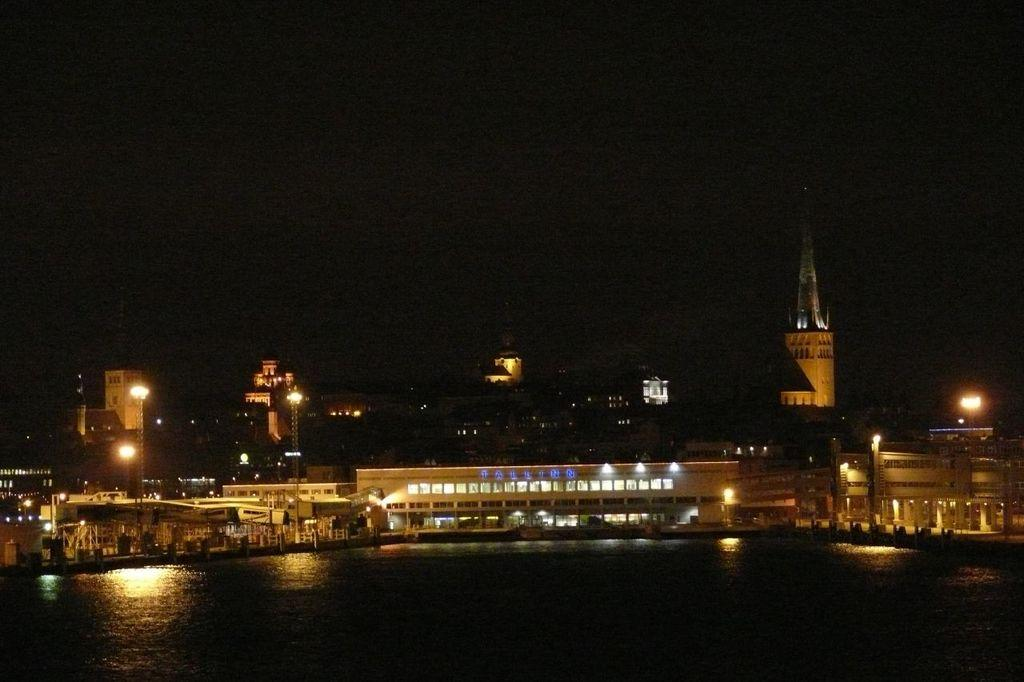What type of structure is present in the image? There is a building in the image. What feature of the building is mentioned in the facts? The building has lights. What natural element is visible in front of the building? There is water visible in front of the building. How would you describe the overall lighting in the image? The background of the image is dark. Can you see any cracks in the building's foundation in the image? There is no mention of cracks in the building's foundation in the provided facts, so we cannot determine their presence from the image. --- Facts: 1. There is a person sitting on a chair in the image. 2. The person is holding a book. 3. The chair is made of wood. 4. There is a table next to the chair. 5. The table has a lamp on it. Absurd Topics: parrot, ocean, bicycle Conversation: What is the person in the image doing? The person is sitting on a chair in the image. What object is the person holding? The person is holding a book. What material is the chair made of? The chair is made of wood. What is located next to the chair? There is a table next to the chair. What item can be seen on the table? The table has a lamp on it. Reasoning: Let's think step by step in order to produce the conversation. We start by identifying the main subject in the image, which is the person sitting on a chair. Then, we expand the conversation to include other details about the person, such as the book they are holding. Next, we mention the material of the chair and the presence of a table next to it. Finally, we describe an item on the table, which is the lamp. Absurd Question/Answer: Can you see a parrot sitting on the person's shoulder in the image? There is no mention of a parrot in the provided facts, so we cannot determine its presence from the image. 